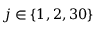Convert formula to latex. <formula><loc_0><loc_0><loc_500><loc_500>j \in \{ 1 , 2 , 3 0 \}</formula> 